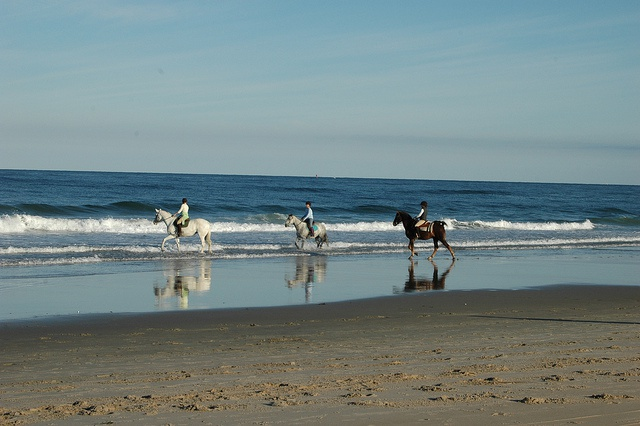Describe the objects in this image and their specific colors. I can see horse in lightblue, black, maroon, and gray tones, horse in lightblue, beige, darkgray, and gray tones, horse in lightblue, gray, darkgray, and black tones, people in lightblue, black, and gray tones, and people in lightblue, beige, black, and darkgray tones in this image. 